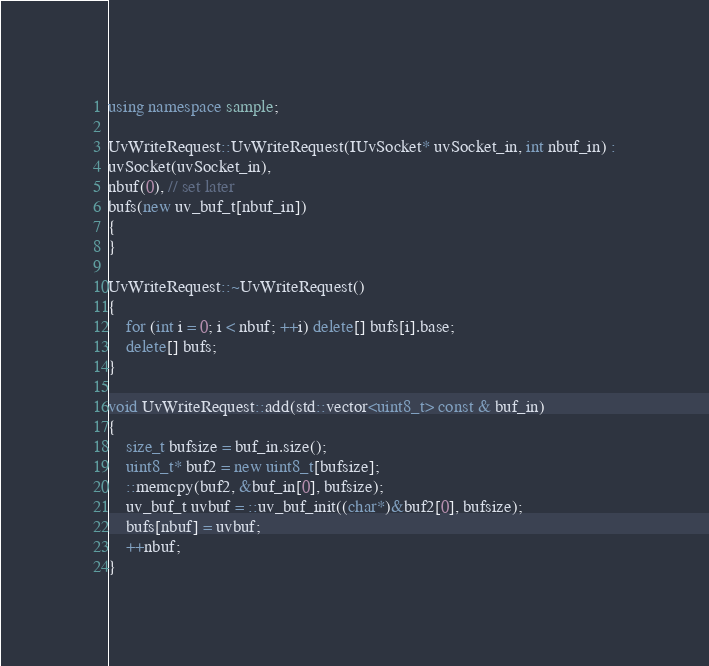<code> <loc_0><loc_0><loc_500><loc_500><_C++_>using namespace sample;

UvWriteRequest::UvWriteRequest(IUvSocket* uvSocket_in, int nbuf_in) :
uvSocket(uvSocket_in),
nbuf(0), // set later
bufs(new uv_buf_t[nbuf_in])
{
}

UvWriteRequest::~UvWriteRequest()
{
    for (int i = 0; i < nbuf; ++i) delete[] bufs[i].base;
    delete[] bufs;
}

void UvWriteRequest::add(std::vector<uint8_t> const & buf_in)
{
    size_t bufsize = buf_in.size();
    uint8_t* buf2 = new uint8_t[bufsize];
    ::memcpy(buf2, &buf_in[0], bufsize);
    uv_buf_t uvbuf = ::uv_buf_init((char*)&buf2[0], bufsize);
    bufs[nbuf] = uvbuf;
    ++nbuf;
}
</code> 